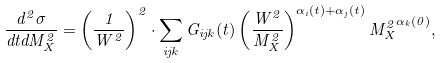Convert formula to latex. <formula><loc_0><loc_0><loc_500><loc_500>\frac { d ^ { 2 } \sigma } { d t d M _ { X } ^ { 2 } } = \left ( \frac { 1 } { W ^ { 2 } } \right ) ^ { 2 } \cdot \sum _ { i j k } G _ { i j k } ( t ) \left ( \frac { W ^ { 2 } } { M _ { X } ^ { 2 } } \right ) ^ { \alpha _ { i } ( t ) + \alpha _ { j } ( t ) } { M _ { X } ^ { 2 } } ^ { \alpha _ { k } ( 0 ) } ,</formula> 